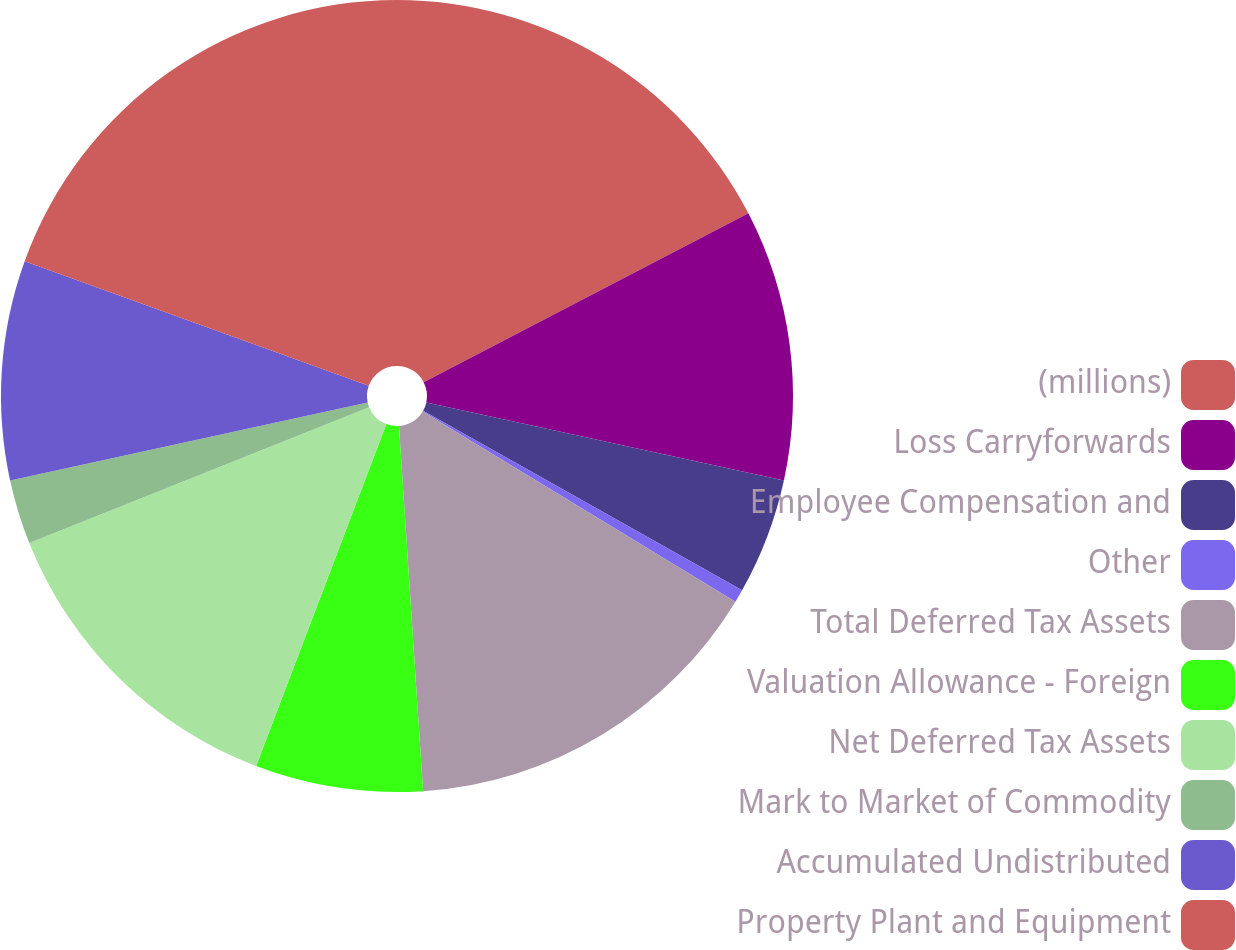Convert chart. <chart><loc_0><loc_0><loc_500><loc_500><pie_chart><fcel>(millions)<fcel>Loss Carryforwards<fcel>Employee Compensation and<fcel>Other<fcel>Total Deferred Tax Assets<fcel>Valuation Allowance - Foreign<fcel>Net Deferred Tax Assets<fcel>Mark to Market of Commodity<fcel>Accumulated Undistributed<fcel>Property Plant and Equipment<nl><fcel>17.37%<fcel>11.05%<fcel>4.74%<fcel>0.53%<fcel>15.26%<fcel>6.84%<fcel>13.16%<fcel>2.63%<fcel>8.95%<fcel>19.47%<nl></chart> 